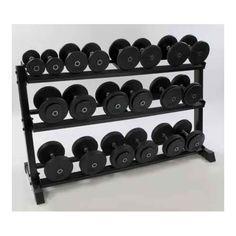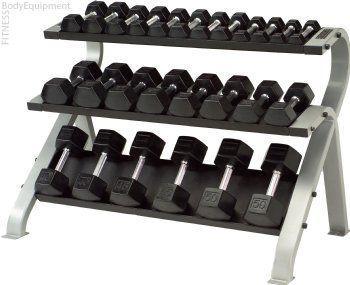The first image is the image on the left, the second image is the image on the right. Given the left and right images, does the statement "The weights sitting in the rack in the image on the left are round in shape." hold true? Answer yes or no. Yes. The first image is the image on the left, the second image is the image on the right. For the images displayed, is the sentence "Left and right racks hold three rows of dumbbells, and dumbbells have the same end shapes in both images." factually correct? Answer yes or no. No. 